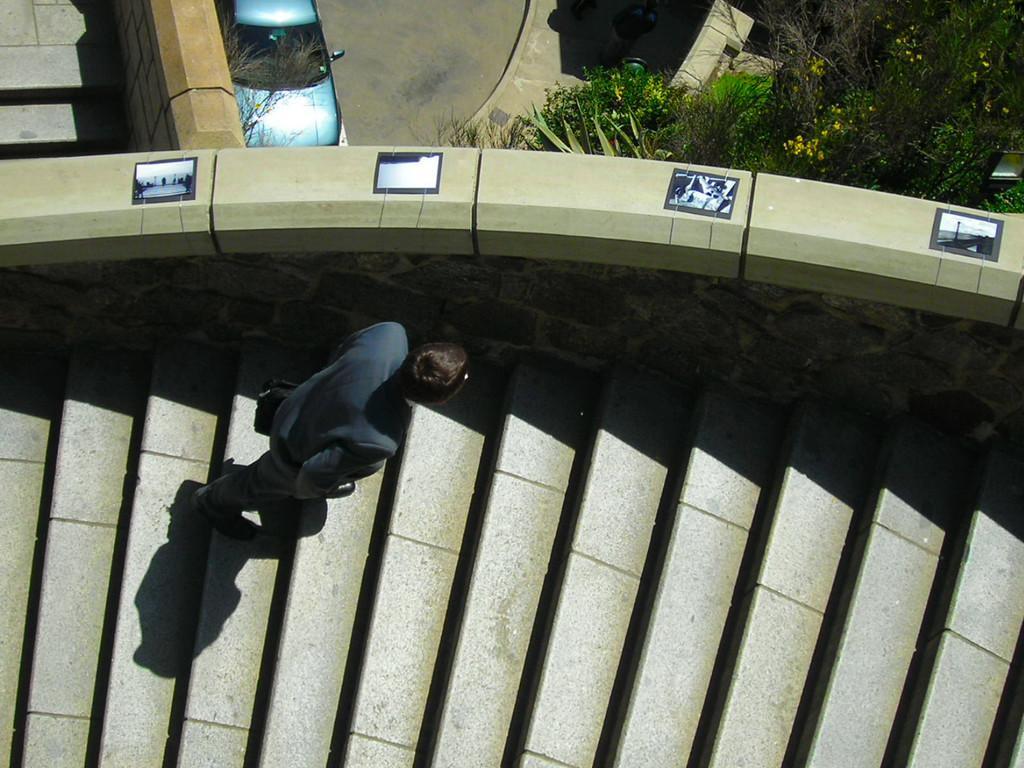In one or two sentences, can you explain what this image depicts? In the image there is a person in suit walking on steps, in the back there is a car on the road with trees in front of it. 